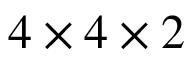<formula> <loc_0><loc_0><loc_500><loc_500>4 \times 4 \times 2</formula> 